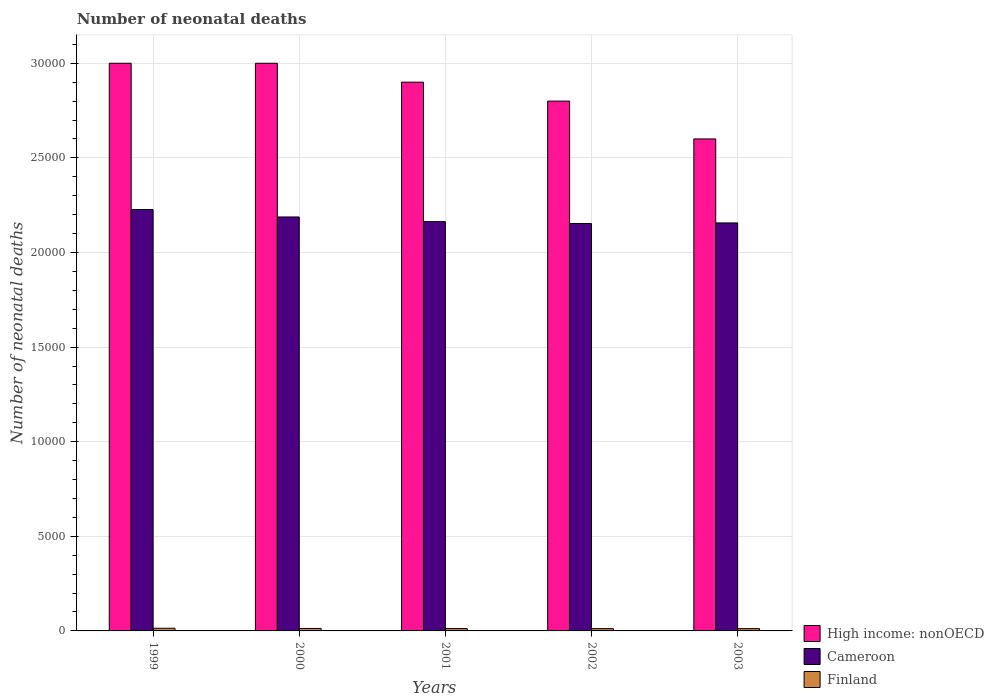How many different coloured bars are there?
Provide a short and direct response. 3. How many groups of bars are there?
Provide a succinct answer. 5. Are the number of bars on each tick of the X-axis equal?
Make the answer very short. Yes. How many bars are there on the 4th tick from the right?
Your answer should be compact. 3. What is the number of neonatal deaths in in Cameroon in 2002?
Ensure brevity in your answer.  2.15e+04. Across all years, what is the maximum number of neonatal deaths in in High income: nonOECD?
Offer a terse response. 3.00e+04. Across all years, what is the minimum number of neonatal deaths in in Finland?
Offer a terse response. 121. In which year was the number of neonatal deaths in in Finland minimum?
Your response must be concise. 2002. What is the total number of neonatal deaths in in Finland in the graph?
Your answer should be compact. 637. What is the difference between the number of neonatal deaths in in Finland in 2000 and that in 2002?
Your answer should be compact. 9. What is the difference between the number of neonatal deaths in in Cameroon in 2000 and the number of neonatal deaths in in Finland in 2001?
Your response must be concise. 2.18e+04. What is the average number of neonatal deaths in in High income: nonOECD per year?
Keep it short and to the point. 2.86e+04. In the year 2001, what is the difference between the number of neonatal deaths in in High income: nonOECD and number of neonatal deaths in in Cameroon?
Provide a succinct answer. 7370. In how many years, is the number of neonatal deaths in in Finland greater than 24000?
Offer a very short reply. 0. What is the ratio of the number of neonatal deaths in in Cameroon in 2001 to that in 2003?
Your response must be concise. 1. What is the difference between the highest and the second highest number of neonatal deaths in in Finland?
Your response must be concise. 11. What is the difference between the highest and the lowest number of neonatal deaths in in Cameroon?
Your answer should be very brief. 738. In how many years, is the number of neonatal deaths in in Cameroon greater than the average number of neonatal deaths in in Cameroon taken over all years?
Ensure brevity in your answer.  2. Is the sum of the number of neonatal deaths in in High income: nonOECD in 2000 and 2003 greater than the maximum number of neonatal deaths in in Cameroon across all years?
Provide a short and direct response. Yes. What does the 1st bar from the left in 1999 represents?
Ensure brevity in your answer.  High income: nonOECD. What does the 2nd bar from the right in 1999 represents?
Ensure brevity in your answer.  Cameroon. Is it the case that in every year, the sum of the number of neonatal deaths in in Finland and number of neonatal deaths in in High income: nonOECD is greater than the number of neonatal deaths in in Cameroon?
Make the answer very short. Yes. How many bars are there?
Your answer should be compact. 15. Are all the bars in the graph horizontal?
Offer a very short reply. No. How many years are there in the graph?
Provide a short and direct response. 5. Where does the legend appear in the graph?
Make the answer very short. Bottom right. How many legend labels are there?
Offer a terse response. 3. How are the legend labels stacked?
Your response must be concise. Vertical. What is the title of the graph?
Your answer should be compact. Number of neonatal deaths. What is the label or title of the Y-axis?
Give a very brief answer. Number of neonatal deaths. What is the Number of neonatal deaths in High income: nonOECD in 1999?
Your answer should be very brief. 3.00e+04. What is the Number of neonatal deaths in Cameroon in 1999?
Offer a terse response. 2.23e+04. What is the Number of neonatal deaths in Finland in 1999?
Keep it short and to the point. 141. What is the Number of neonatal deaths of High income: nonOECD in 2000?
Ensure brevity in your answer.  3.00e+04. What is the Number of neonatal deaths in Cameroon in 2000?
Provide a succinct answer. 2.19e+04. What is the Number of neonatal deaths in Finland in 2000?
Ensure brevity in your answer.  130. What is the Number of neonatal deaths in High income: nonOECD in 2001?
Provide a short and direct response. 2.90e+04. What is the Number of neonatal deaths in Cameroon in 2001?
Provide a short and direct response. 2.16e+04. What is the Number of neonatal deaths in Finland in 2001?
Ensure brevity in your answer.  124. What is the Number of neonatal deaths in High income: nonOECD in 2002?
Provide a short and direct response. 2.80e+04. What is the Number of neonatal deaths in Cameroon in 2002?
Ensure brevity in your answer.  2.15e+04. What is the Number of neonatal deaths in Finland in 2002?
Keep it short and to the point. 121. What is the Number of neonatal deaths of High income: nonOECD in 2003?
Make the answer very short. 2.60e+04. What is the Number of neonatal deaths of Cameroon in 2003?
Offer a terse response. 2.16e+04. What is the Number of neonatal deaths in Finland in 2003?
Give a very brief answer. 121. Across all years, what is the maximum Number of neonatal deaths in High income: nonOECD?
Ensure brevity in your answer.  3.00e+04. Across all years, what is the maximum Number of neonatal deaths in Cameroon?
Keep it short and to the point. 2.23e+04. Across all years, what is the maximum Number of neonatal deaths of Finland?
Keep it short and to the point. 141. Across all years, what is the minimum Number of neonatal deaths in High income: nonOECD?
Offer a terse response. 2.60e+04. Across all years, what is the minimum Number of neonatal deaths in Cameroon?
Provide a succinct answer. 2.15e+04. Across all years, what is the minimum Number of neonatal deaths of Finland?
Your answer should be compact. 121. What is the total Number of neonatal deaths in High income: nonOECD in the graph?
Your answer should be compact. 1.43e+05. What is the total Number of neonatal deaths of Cameroon in the graph?
Give a very brief answer. 1.09e+05. What is the total Number of neonatal deaths in Finland in the graph?
Ensure brevity in your answer.  637. What is the difference between the Number of neonatal deaths of Cameroon in 1999 and that in 2000?
Your answer should be very brief. 394. What is the difference between the Number of neonatal deaths in Finland in 1999 and that in 2000?
Offer a terse response. 11. What is the difference between the Number of neonatal deaths in High income: nonOECD in 1999 and that in 2001?
Ensure brevity in your answer.  1000. What is the difference between the Number of neonatal deaths in Cameroon in 1999 and that in 2001?
Your response must be concise. 640. What is the difference between the Number of neonatal deaths of Finland in 1999 and that in 2001?
Your answer should be compact. 17. What is the difference between the Number of neonatal deaths of High income: nonOECD in 1999 and that in 2002?
Your answer should be compact. 2000. What is the difference between the Number of neonatal deaths in Cameroon in 1999 and that in 2002?
Your answer should be very brief. 738. What is the difference between the Number of neonatal deaths in Finland in 1999 and that in 2002?
Your answer should be very brief. 20. What is the difference between the Number of neonatal deaths in High income: nonOECD in 1999 and that in 2003?
Provide a short and direct response. 4000. What is the difference between the Number of neonatal deaths in Cameroon in 1999 and that in 2003?
Offer a very short reply. 708. What is the difference between the Number of neonatal deaths in Finland in 1999 and that in 2003?
Provide a short and direct response. 20. What is the difference between the Number of neonatal deaths in High income: nonOECD in 2000 and that in 2001?
Ensure brevity in your answer.  1000. What is the difference between the Number of neonatal deaths of Cameroon in 2000 and that in 2001?
Keep it short and to the point. 246. What is the difference between the Number of neonatal deaths in Finland in 2000 and that in 2001?
Make the answer very short. 6. What is the difference between the Number of neonatal deaths of Cameroon in 2000 and that in 2002?
Offer a very short reply. 344. What is the difference between the Number of neonatal deaths of High income: nonOECD in 2000 and that in 2003?
Provide a short and direct response. 4000. What is the difference between the Number of neonatal deaths of Cameroon in 2000 and that in 2003?
Provide a short and direct response. 314. What is the difference between the Number of neonatal deaths of Finland in 2001 and that in 2002?
Your answer should be very brief. 3. What is the difference between the Number of neonatal deaths of High income: nonOECD in 2001 and that in 2003?
Make the answer very short. 3000. What is the difference between the Number of neonatal deaths of Cameroon in 2001 and that in 2003?
Your answer should be very brief. 68. What is the difference between the Number of neonatal deaths in Finland in 2001 and that in 2003?
Give a very brief answer. 3. What is the difference between the Number of neonatal deaths in High income: nonOECD in 2002 and that in 2003?
Your response must be concise. 2000. What is the difference between the Number of neonatal deaths in Cameroon in 2002 and that in 2003?
Your answer should be compact. -30. What is the difference between the Number of neonatal deaths in Finland in 2002 and that in 2003?
Make the answer very short. 0. What is the difference between the Number of neonatal deaths of High income: nonOECD in 1999 and the Number of neonatal deaths of Cameroon in 2000?
Provide a succinct answer. 8124. What is the difference between the Number of neonatal deaths of High income: nonOECD in 1999 and the Number of neonatal deaths of Finland in 2000?
Your answer should be very brief. 2.99e+04. What is the difference between the Number of neonatal deaths in Cameroon in 1999 and the Number of neonatal deaths in Finland in 2000?
Your answer should be very brief. 2.21e+04. What is the difference between the Number of neonatal deaths in High income: nonOECD in 1999 and the Number of neonatal deaths in Cameroon in 2001?
Offer a very short reply. 8370. What is the difference between the Number of neonatal deaths of High income: nonOECD in 1999 and the Number of neonatal deaths of Finland in 2001?
Provide a succinct answer. 2.99e+04. What is the difference between the Number of neonatal deaths in Cameroon in 1999 and the Number of neonatal deaths in Finland in 2001?
Give a very brief answer. 2.21e+04. What is the difference between the Number of neonatal deaths of High income: nonOECD in 1999 and the Number of neonatal deaths of Cameroon in 2002?
Give a very brief answer. 8468. What is the difference between the Number of neonatal deaths of High income: nonOECD in 1999 and the Number of neonatal deaths of Finland in 2002?
Offer a very short reply. 2.99e+04. What is the difference between the Number of neonatal deaths of Cameroon in 1999 and the Number of neonatal deaths of Finland in 2002?
Offer a very short reply. 2.21e+04. What is the difference between the Number of neonatal deaths of High income: nonOECD in 1999 and the Number of neonatal deaths of Cameroon in 2003?
Your answer should be compact. 8438. What is the difference between the Number of neonatal deaths of High income: nonOECD in 1999 and the Number of neonatal deaths of Finland in 2003?
Your answer should be compact. 2.99e+04. What is the difference between the Number of neonatal deaths in Cameroon in 1999 and the Number of neonatal deaths in Finland in 2003?
Provide a succinct answer. 2.21e+04. What is the difference between the Number of neonatal deaths of High income: nonOECD in 2000 and the Number of neonatal deaths of Cameroon in 2001?
Your answer should be very brief. 8370. What is the difference between the Number of neonatal deaths in High income: nonOECD in 2000 and the Number of neonatal deaths in Finland in 2001?
Provide a short and direct response. 2.99e+04. What is the difference between the Number of neonatal deaths in Cameroon in 2000 and the Number of neonatal deaths in Finland in 2001?
Keep it short and to the point. 2.18e+04. What is the difference between the Number of neonatal deaths in High income: nonOECD in 2000 and the Number of neonatal deaths in Cameroon in 2002?
Offer a very short reply. 8468. What is the difference between the Number of neonatal deaths in High income: nonOECD in 2000 and the Number of neonatal deaths in Finland in 2002?
Keep it short and to the point. 2.99e+04. What is the difference between the Number of neonatal deaths in Cameroon in 2000 and the Number of neonatal deaths in Finland in 2002?
Ensure brevity in your answer.  2.18e+04. What is the difference between the Number of neonatal deaths of High income: nonOECD in 2000 and the Number of neonatal deaths of Cameroon in 2003?
Offer a very short reply. 8438. What is the difference between the Number of neonatal deaths in High income: nonOECD in 2000 and the Number of neonatal deaths in Finland in 2003?
Your answer should be compact. 2.99e+04. What is the difference between the Number of neonatal deaths of Cameroon in 2000 and the Number of neonatal deaths of Finland in 2003?
Make the answer very short. 2.18e+04. What is the difference between the Number of neonatal deaths of High income: nonOECD in 2001 and the Number of neonatal deaths of Cameroon in 2002?
Give a very brief answer. 7468. What is the difference between the Number of neonatal deaths in High income: nonOECD in 2001 and the Number of neonatal deaths in Finland in 2002?
Your response must be concise. 2.89e+04. What is the difference between the Number of neonatal deaths in Cameroon in 2001 and the Number of neonatal deaths in Finland in 2002?
Offer a terse response. 2.15e+04. What is the difference between the Number of neonatal deaths in High income: nonOECD in 2001 and the Number of neonatal deaths in Cameroon in 2003?
Offer a very short reply. 7438. What is the difference between the Number of neonatal deaths in High income: nonOECD in 2001 and the Number of neonatal deaths in Finland in 2003?
Ensure brevity in your answer.  2.89e+04. What is the difference between the Number of neonatal deaths of Cameroon in 2001 and the Number of neonatal deaths of Finland in 2003?
Your answer should be very brief. 2.15e+04. What is the difference between the Number of neonatal deaths of High income: nonOECD in 2002 and the Number of neonatal deaths of Cameroon in 2003?
Provide a short and direct response. 6438. What is the difference between the Number of neonatal deaths in High income: nonOECD in 2002 and the Number of neonatal deaths in Finland in 2003?
Your answer should be compact. 2.79e+04. What is the difference between the Number of neonatal deaths of Cameroon in 2002 and the Number of neonatal deaths of Finland in 2003?
Your response must be concise. 2.14e+04. What is the average Number of neonatal deaths in High income: nonOECD per year?
Give a very brief answer. 2.86e+04. What is the average Number of neonatal deaths of Cameroon per year?
Make the answer very short. 2.18e+04. What is the average Number of neonatal deaths in Finland per year?
Offer a very short reply. 127.4. In the year 1999, what is the difference between the Number of neonatal deaths of High income: nonOECD and Number of neonatal deaths of Cameroon?
Keep it short and to the point. 7730. In the year 1999, what is the difference between the Number of neonatal deaths of High income: nonOECD and Number of neonatal deaths of Finland?
Provide a short and direct response. 2.99e+04. In the year 1999, what is the difference between the Number of neonatal deaths of Cameroon and Number of neonatal deaths of Finland?
Make the answer very short. 2.21e+04. In the year 2000, what is the difference between the Number of neonatal deaths in High income: nonOECD and Number of neonatal deaths in Cameroon?
Make the answer very short. 8124. In the year 2000, what is the difference between the Number of neonatal deaths of High income: nonOECD and Number of neonatal deaths of Finland?
Your response must be concise. 2.99e+04. In the year 2000, what is the difference between the Number of neonatal deaths in Cameroon and Number of neonatal deaths in Finland?
Offer a terse response. 2.17e+04. In the year 2001, what is the difference between the Number of neonatal deaths in High income: nonOECD and Number of neonatal deaths in Cameroon?
Your answer should be very brief. 7370. In the year 2001, what is the difference between the Number of neonatal deaths of High income: nonOECD and Number of neonatal deaths of Finland?
Ensure brevity in your answer.  2.89e+04. In the year 2001, what is the difference between the Number of neonatal deaths of Cameroon and Number of neonatal deaths of Finland?
Ensure brevity in your answer.  2.15e+04. In the year 2002, what is the difference between the Number of neonatal deaths in High income: nonOECD and Number of neonatal deaths in Cameroon?
Give a very brief answer. 6468. In the year 2002, what is the difference between the Number of neonatal deaths of High income: nonOECD and Number of neonatal deaths of Finland?
Provide a succinct answer. 2.79e+04. In the year 2002, what is the difference between the Number of neonatal deaths in Cameroon and Number of neonatal deaths in Finland?
Give a very brief answer. 2.14e+04. In the year 2003, what is the difference between the Number of neonatal deaths of High income: nonOECD and Number of neonatal deaths of Cameroon?
Your answer should be compact. 4438. In the year 2003, what is the difference between the Number of neonatal deaths in High income: nonOECD and Number of neonatal deaths in Finland?
Provide a succinct answer. 2.59e+04. In the year 2003, what is the difference between the Number of neonatal deaths of Cameroon and Number of neonatal deaths of Finland?
Keep it short and to the point. 2.14e+04. What is the ratio of the Number of neonatal deaths of Finland in 1999 to that in 2000?
Make the answer very short. 1.08. What is the ratio of the Number of neonatal deaths of High income: nonOECD in 1999 to that in 2001?
Keep it short and to the point. 1.03. What is the ratio of the Number of neonatal deaths in Cameroon in 1999 to that in 2001?
Keep it short and to the point. 1.03. What is the ratio of the Number of neonatal deaths in Finland in 1999 to that in 2001?
Your response must be concise. 1.14. What is the ratio of the Number of neonatal deaths in High income: nonOECD in 1999 to that in 2002?
Your answer should be compact. 1.07. What is the ratio of the Number of neonatal deaths of Cameroon in 1999 to that in 2002?
Ensure brevity in your answer.  1.03. What is the ratio of the Number of neonatal deaths of Finland in 1999 to that in 2002?
Give a very brief answer. 1.17. What is the ratio of the Number of neonatal deaths in High income: nonOECD in 1999 to that in 2003?
Ensure brevity in your answer.  1.15. What is the ratio of the Number of neonatal deaths of Cameroon in 1999 to that in 2003?
Make the answer very short. 1.03. What is the ratio of the Number of neonatal deaths in Finland in 1999 to that in 2003?
Make the answer very short. 1.17. What is the ratio of the Number of neonatal deaths in High income: nonOECD in 2000 to that in 2001?
Offer a very short reply. 1.03. What is the ratio of the Number of neonatal deaths in Cameroon in 2000 to that in 2001?
Provide a short and direct response. 1.01. What is the ratio of the Number of neonatal deaths in Finland in 2000 to that in 2001?
Ensure brevity in your answer.  1.05. What is the ratio of the Number of neonatal deaths in High income: nonOECD in 2000 to that in 2002?
Ensure brevity in your answer.  1.07. What is the ratio of the Number of neonatal deaths in Cameroon in 2000 to that in 2002?
Give a very brief answer. 1.02. What is the ratio of the Number of neonatal deaths of Finland in 2000 to that in 2002?
Offer a very short reply. 1.07. What is the ratio of the Number of neonatal deaths in High income: nonOECD in 2000 to that in 2003?
Your response must be concise. 1.15. What is the ratio of the Number of neonatal deaths of Cameroon in 2000 to that in 2003?
Provide a succinct answer. 1.01. What is the ratio of the Number of neonatal deaths in Finland in 2000 to that in 2003?
Give a very brief answer. 1.07. What is the ratio of the Number of neonatal deaths of High income: nonOECD in 2001 to that in 2002?
Provide a succinct answer. 1.04. What is the ratio of the Number of neonatal deaths in Finland in 2001 to that in 2002?
Offer a very short reply. 1.02. What is the ratio of the Number of neonatal deaths of High income: nonOECD in 2001 to that in 2003?
Your answer should be very brief. 1.12. What is the ratio of the Number of neonatal deaths of Finland in 2001 to that in 2003?
Your response must be concise. 1.02. What is the ratio of the Number of neonatal deaths of High income: nonOECD in 2002 to that in 2003?
Provide a short and direct response. 1.08. What is the ratio of the Number of neonatal deaths of Cameroon in 2002 to that in 2003?
Ensure brevity in your answer.  1. What is the difference between the highest and the second highest Number of neonatal deaths in Cameroon?
Make the answer very short. 394. What is the difference between the highest and the second highest Number of neonatal deaths of Finland?
Give a very brief answer. 11. What is the difference between the highest and the lowest Number of neonatal deaths of High income: nonOECD?
Your answer should be very brief. 4000. What is the difference between the highest and the lowest Number of neonatal deaths in Cameroon?
Offer a very short reply. 738. What is the difference between the highest and the lowest Number of neonatal deaths of Finland?
Give a very brief answer. 20. 